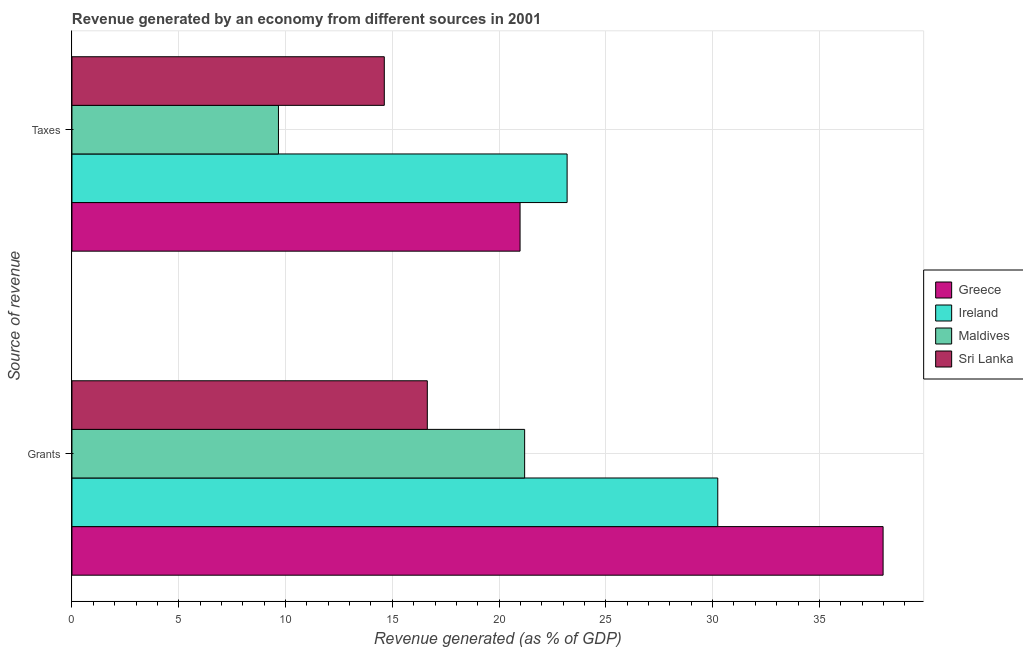How many different coloured bars are there?
Give a very brief answer. 4. What is the label of the 2nd group of bars from the top?
Keep it short and to the point. Grants. What is the revenue generated by grants in Maldives?
Your answer should be compact. 21.2. Across all countries, what is the maximum revenue generated by taxes?
Your response must be concise. 23.19. Across all countries, what is the minimum revenue generated by taxes?
Your answer should be compact. 9.67. In which country was the revenue generated by taxes maximum?
Ensure brevity in your answer.  Ireland. In which country was the revenue generated by grants minimum?
Give a very brief answer. Sri Lanka. What is the total revenue generated by taxes in the graph?
Provide a short and direct response. 68.46. What is the difference between the revenue generated by grants in Greece and that in Sri Lanka?
Provide a succinct answer. 21.34. What is the difference between the revenue generated by grants in Greece and the revenue generated by taxes in Sri Lanka?
Keep it short and to the point. 23.36. What is the average revenue generated by taxes per country?
Ensure brevity in your answer.  17.12. What is the difference between the revenue generated by taxes and revenue generated by grants in Greece?
Offer a terse response. -17. What is the ratio of the revenue generated by grants in Ireland to that in Sri Lanka?
Offer a terse response. 1.82. What does the 2nd bar from the top in Grants represents?
Offer a terse response. Maldives. What does the 4th bar from the bottom in Taxes represents?
Your response must be concise. Sri Lanka. How many bars are there?
Your response must be concise. 8. How many countries are there in the graph?
Your answer should be compact. 4. What is the difference between two consecutive major ticks on the X-axis?
Your answer should be compact. 5. Does the graph contain any zero values?
Provide a succinct answer. No. How many legend labels are there?
Your answer should be very brief. 4. What is the title of the graph?
Ensure brevity in your answer.  Revenue generated by an economy from different sources in 2001. What is the label or title of the X-axis?
Your answer should be very brief. Revenue generated (as % of GDP). What is the label or title of the Y-axis?
Ensure brevity in your answer.  Source of revenue. What is the Revenue generated (as % of GDP) in Greece in Grants?
Your response must be concise. 37.98. What is the Revenue generated (as % of GDP) of Ireland in Grants?
Your answer should be very brief. 30.24. What is the Revenue generated (as % of GDP) in Maldives in Grants?
Offer a very short reply. 21.2. What is the Revenue generated (as % of GDP) of Sri Lanka in Grants?
Provide a succinct answer. 16.64. What is the Revenue generated (as % of GDP) in Greece in Taxes?
Make the answer very short. 20.98. What is the Revenue generated (as % of GDP) in Ireland in Taxes?
Your answer should be very brief. 23.19. What is the Revenue generated (as % of GDP) in Maldives in Taxes?
Ensure brevity in your answer.  9.67. What is the Revenue generated (as % of GDP) in Sri Lanka in Taxes?
Give a very brief answer. 14.63. Across all Source of revenue, what is the maximum Revenue generated (as % of GDP) in Greece?
Give a very brief answer. 37.98. Across all Source of revenue, what is the maximum Revenue generated (as % of GDP) of Ireland?
Offer a terse response. 30.24. Across all Source of revenue, what is the maximum Revenue generated (as % of GDP) in Maldives?
Your answer should be compact. 21.2. Across all Source of revenue, what is the maximum Revenue generated (as % of GDP) in Sri Lanka?
Offer a terse response. 16.64. Across all Source of revenue, what is the minimum Revenue generated (as % of GDP) of Greece?
Keep it short and to the point. 20.98. Across all Source of revenue, what is the minimum Revenue generated (as % of GDP) in Ireland?
Provide a succinct answer. 23.19. Across all Source of revenue, what is the minimum Revenue generated (as % of GDP) of Maldives?
Provide a short and direct response. 9.67. Across all Source of revenue, what is the minimum Revenue generated (as % of GDP) in Sri Lanka?
Provide a succinct answer. 14.63. What is the total Revenue generated (as % of GDP) in Greece in the graph?
Make the answer very short. 58.96. What is the total Revenue generated (as % of GDP) of Ireland in the graph?
Your answer should be very brief. 53.43. What is the total Revenue generated (as % of GDP) of Maldives in the graph?
Provide a short and direct response. 30.87. What is the total Revenue generated (as % of GDP) of Sri Lanka in the graph?
Your answer should be very brief. 31.27. What is the difference between the Revenue generated (as % of GDP) in Greece in Grants and that in Taxes?
Offer a terse response. 17. What is the difference between the Revenue generated (as % of GDP) of Ireland in Grants and that in Taxes?
Ensure brevity in your answer.  7.05. What is the difference between the Revenue generated (as % of GDP) of Maldives in Grants and that in Taxes?
Provide a succinct answer. 11.53. What is the difference between the Revenue generated (as % of GDP) of Sri Lanka in Grants and that in Taxes?
Provide a succinct answer. 2.01. What is the difference between the Revenue generated (as % of GDP) of Greece in Grants and the Revenue generated (as % of GDP) of Ireland in Taxes?
Provide a short and direct response. 14.8. What is the difference between the Revenue generated (as % of GDP) of Greece in Grants and the Revenue generated (as % of GDP) of Maldives in Taxes?
Ensure brevity in your answer.  28.31. What is the difference between the Revenue generated (as % of GDP) of Greece in Grants and the Revenue generated (as % of GDP) of Sri Lanka in Taxes?
Your answer should be compact. 23.36. What is the difference between the Revenue generated (as % of GDP) of Ireland in Grants and the Revenue generated (as % of GDP) of Maldives in Taxes?
Your answer should be compact. 20.57. What is the difference between the Revenue generated (as % of GDP) of Ireland in Grants and the Revenue generated (as % of GDP) of Sri Lanka in Taxes?
Provide a succinct answer. 15.61. What is the difference between the Revenue generated (as % of GDP) in Maldives in Grants and the Revenue generated (as % of GDP) in Sri Lanka in Taxes?
Your response must be concise. 6.57. What is the average Revenue generated (as % of GDP) in Greece per Source of revenue?
Provide a succinct answer. 29.48. What is the average Revenue generated (as % of GDP) of Ireland per Source of revenue?
Make the answer very short. 26.71. What is the average Revenue generated (as % of GDP) in Maldives per Source of revenue?
Make the answer very short. 15.43. What is the average Revenue generated (as % of GDP) of Sri Lanka per Source of revenue?
Offer a terse response. 15.63. What is the difference between the Revenue generated (as % of GDP) of Greece and Revenue generated (as % of GDP) of Ireland in Grants?
Offer a terse response. 7.74. What is the difference between the Revenue generated (as % of GDP) in Greece and Revenue generated (as % of GDP) in Maldives in Grants?
Provide a short and direct response. 16.78. What is the difference between the Revenue generated (as % of GDP) of Greece and Revenue generated (as % of GDP) of Sri Lanka in Grants?
Offer a very short reply. 21.34. What is the difference between the Revenue generated (as % of GDP) of Ireland and Revenue generated (as % of GDP) of Maldives in Grants?
Provide a short and direct response. 9.04. What is the difference between the Revenue generated (as % of GDP) in Ireland and Revenue generated (as % of GDP) in Sri Lanka in Grants?
Keep it short and to the point. 13.6. What is the difference between the Revenue generated (as % of GDP) in Maldives and Revenue generated (as % of GDP) in Sri Lanka in Grants?
Keep it short and to the point. 4.56. What is the difference between the Revenue generated (as % of GDP) in Greece and Revenue generated (as % of GDP) in Ireland in Taxes?
Keep it short and to the point. -2.2. What is the difference between the Revenue generated (as % of GDP) of Greece and Revenue generated (as % of GDP) of Maldives in Taxes?
Your response must be concise. 11.31. What is the difference between the Revenue generated (as % of GDP) of Greece and Revenue generated (as % of GDP) of Sri Lanka in Taxes?
Give a very brief answer. 6.36. What is the difference between the Revenue generated (as % of GDP) of Ireland and Revenue generated (as % of GDP) of Maldives in Taxes?
Make the answer very short. 13.52. What is the difference between the Revenue generated (as % of GDP) of Ireland and Revenue generated (as % of GDP) of Sri Lanka in Taxes?
Offer a very short reply. 8.56. What is the difference between the Revenue generated (as % of GDP) in Maldives and Revenue generated (as % of GDP) in Sri Lanka in Taxes?
Offer a very short reply. -4.96. What is the ratio of the Revenue generated (as % of GDP) of Greece in Grants to that in Taxes?
Offer a very short reply. 1.81. What is the ratio of the Revenue generated (as % of GDP) in Ireland in Grants to that in Taxes?
Your answer should be compact. 1.3. What is the ratio of the Revenue generated (as % of GDP) of Maldives in Grants to that in Taxes?
Give a very brief answer. 2.19. What is the ratio of the Revenue generated (as % of GDP) of Sri Lanka in Grants to that in Taxes?
Your answer should be very brief. 1.14. What is the difference between the highest and the second highest Revenue generated (as % of GDP) of Greece?
Offer a very short reply. 17. What is the difference between the highest and the second highest Revenue generated (as % of GDP) of Ireland?
Your response must be concise. 7.05. What is the difference between the highest and the second highest Revenue generated (as % of GDP) of Maldives?
Give a very brief answer. 11.53. What is the difference between the highest and the second highest Revenue generated (as % of GDP) of Sri Lanka?
Ensure brevity in your answer.  2.01. What is the difference between the highest and the lowest Revenue generated (as % of GDP) of Greece?
Your answer should be very brief. 17. What is the difference between the highest and the lowest Revenue generated (as % of GDP) in Ireland?
Provide a short and direct response. 7.05. What is the difference between the highest and the lowest Revenue generated (as % of GDP) in Maldives?
Ensure brevity in your answer.  11.53. What is the difference between the highest and the lowest Revenue generated (as % of GDP) of Sri Lanka?
Give a very brief answer. 2.01. 